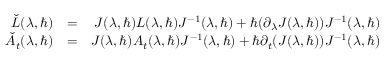Convert formula to latex. <formula><loc_0><loc_0><loc_500><loc_500>\begin{array} { r l r } { \check { L } ( \lambda , \hbar { ) } } & { = } & { J ( \lambda , \hbar { ) } L ( \lambda , \hbar { ) } J ^ { - 1 } ( \lambda , \hbar { ) } + \hbar { ( } \partial _ { \lambda } J ( \lambda , \hbar { ) } ) J ^ { - 1 } ( \lambda , \hbar { ) } } \\ { \check { A } _ { t } ( \lambda , \hbar { ) } } & { = } & { J ( \lambda , \hbar { ) } A _ { t } ( \lambda , \hbar { ) } J ^ { - 1 } ( \lambda , \hbar { ) } + \hbar { \partial } _ { t } ( J ( \lambda , \hbar { ) } ) J ^ { - 1 } ( \lambda , \hbar { ) } } \end{array}</formula> 